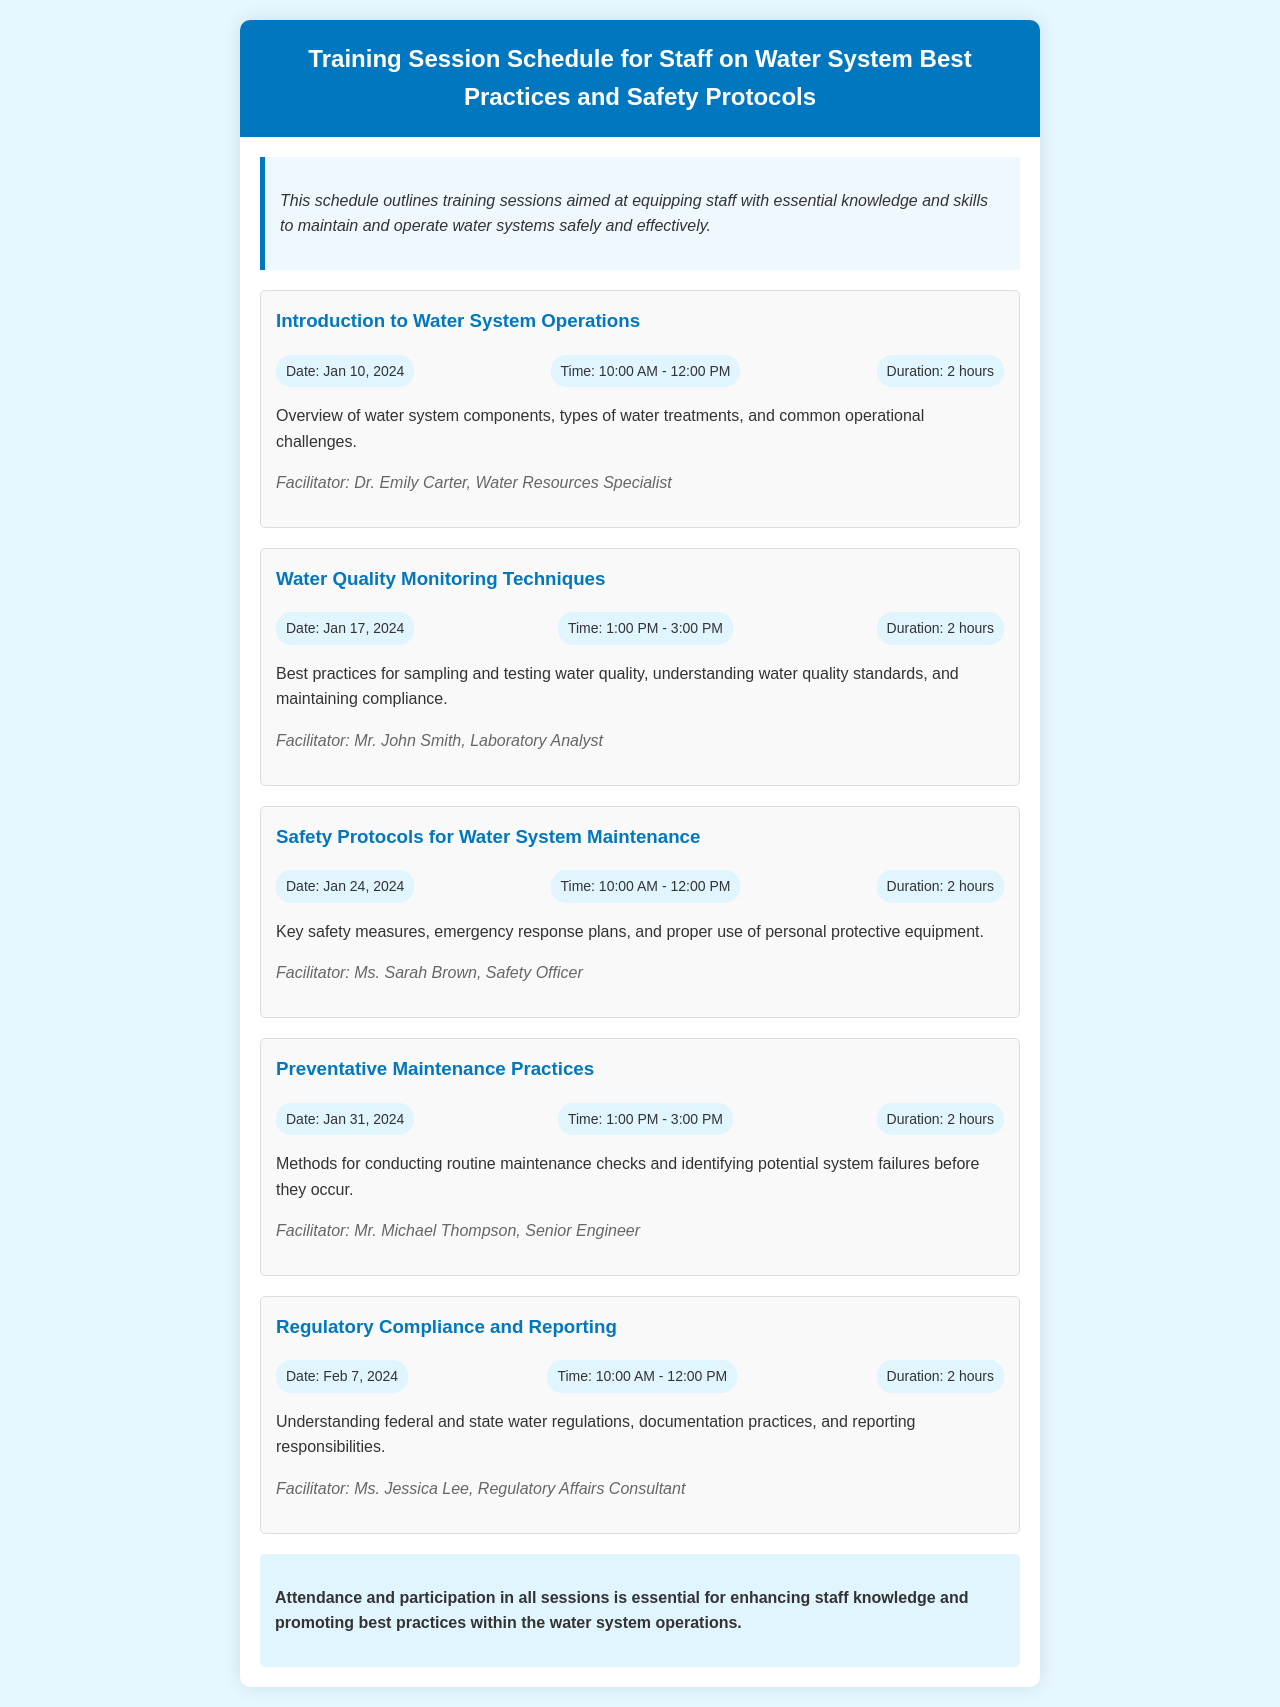What is the title of the document? The title of the document is displayed prominently in the header section.
Answer: Training Session Schedule for Staff on Water System Best Practices and Safety Protocols Who is the facilitator for the session on Water Quality Monitoring Techniques? The facilitator's name is mentioned at the end of the overview for that session.
Answer: Mr. John Smith What date is the session on Safety Protocols scheduled? The date is provided in the session information for the relevant training session.
Answer: Jan 24, 2024 How long is each training session scheduled to last? The duration is uniformly stated in each session information section.
Answer: 2 hours What is the main focus of the session titled Preventative Maintenance Practices? The description after the title gives insight into the focus of that session.
Answer: Methods for conducting routine maintenance checks and identifying potential system failures before they occur How many training sessions are outlined in the document? The total number of sessions can be counted from the individual session sections.
Answer: Five What is the background color of the overview section? The background color of the overview section can be observed visually in the document layout.
Answer: #f0f8ff Who facilitates the introductory session? The name of the facilitator is provided in the details regarding that specific session.
Answer: Dr. Emily Carter What is the concluding advice given in the document? The conclusion section states the importance of attendance and participation in the sessions.
Answer: Attendance and participation in all sessions is essential for enhancing staff knowledge and promoting best practices within the water system operations 